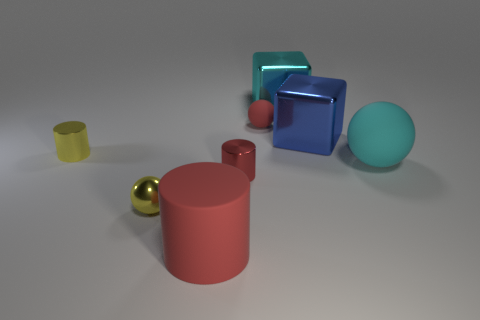Add 1 tiny brown metallic cylinders. How many objects exist? 9 Subtract all blocks. How many objects are left? 6 Subtract all tiny balls. How many balls are left? 1 Subtract 0 brown spheres. How many objects are left? 8 Subtract 1 balls. How many balls are left? 2 Subtract all blue cubes. Subtract all blue cylinders. How many cubes are left? 1 Subtract all yellow balls. How many blue blocks are left? 1 Subtract all small red shiny cylinders. Subtract all yellow metallic cylinders. How many objects are left? 6 Add 1 cyan matte balls. How many cyan matte balls are left? 2 Add 8 tiny yellow metallic cylinders. How many tiny yellow metallic cylinders exist? 9 